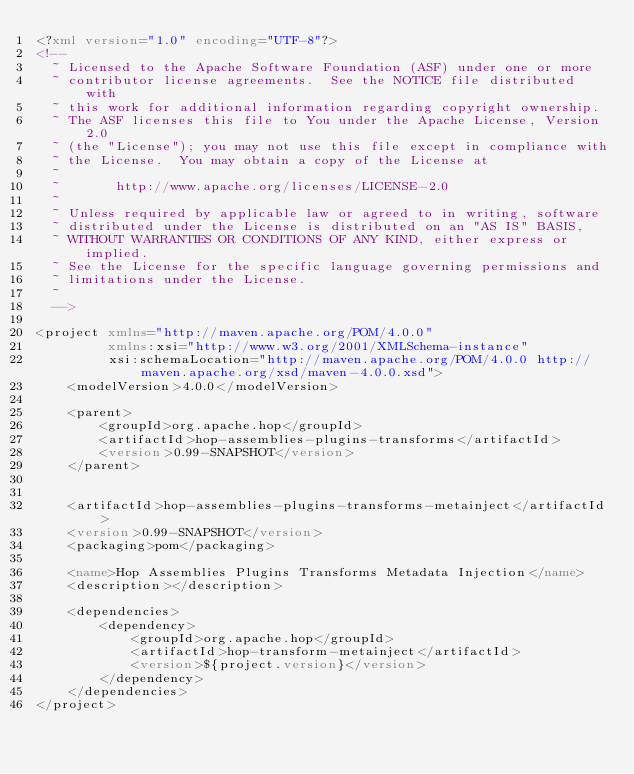<code> <loc_0><loc_0><loc_500><loc_500><_XML_><?xml version="1.0" encoding="UTF-8"?>
<!--
  ~ Licensed to the Apache Software Foundation (ASF) under one or more
  ~ contributor license agreements.  See the NOTICE file distributed with
  ~ this work for additional information regarding copyright ownership.
  ~ The ASF licenses this file to You under the Apache License, Version 2.0
  ~ (the "License"); you may not use this file except in compliance with
  ~ the License.  You may obtain a copy of the License at
  ~
  ~       http://www.apache.org/licenses/LICENSE-2.0
  ~
  ~ Unless required by applicable law or agreed to in writing, software
  ~ distributed under the License is distributed on an "AS IS" BASIS,
  ~ WITHOUT WARRANTIES OR CONDITIONS OF ANY KIND, either express or implied.
  ~ See the License for the specific language governing permissions and
  ~ limitations under the License.
  ~
  -->

<project xmlns="http://maven.apache.org/POM/4.0.0"
         xmlns:xsi="http://www.w3.org/2001/XMLSchema-instance"
         xsi:schemaLocation="http://maven.apache.org/POM/4.0.0 http://maven.apache.org/xsd/maven-4.0.0.xsd">
    <modelVersion>4.0.0</modelVersion>

    <parent>
        <groupId>org.apache.hop</groupId>
        <artifactId>hop-assemblies-plugins-transforms</artifactId>
        <version>0.99-SNAPSHOT</version>
    </parent>


    <artifactId>hop-assemblies-plugins-transforms-metainject</artifactId>
    <version>0.99-SNAPSHOT</version>
    <packaging>pom</packaging>

    <name>Hop Assemblies Plugins Transforms Metadata Injection</name>
    <description></description>

    <dependencies>
        <dependency>
            <groupId>org.apache.hop</groupId>
            <artifactId>hop-transform-metainject</artifactId>
            <version>${project.version}</version>
        </dependency>
    </dependencies>
</project></code> 